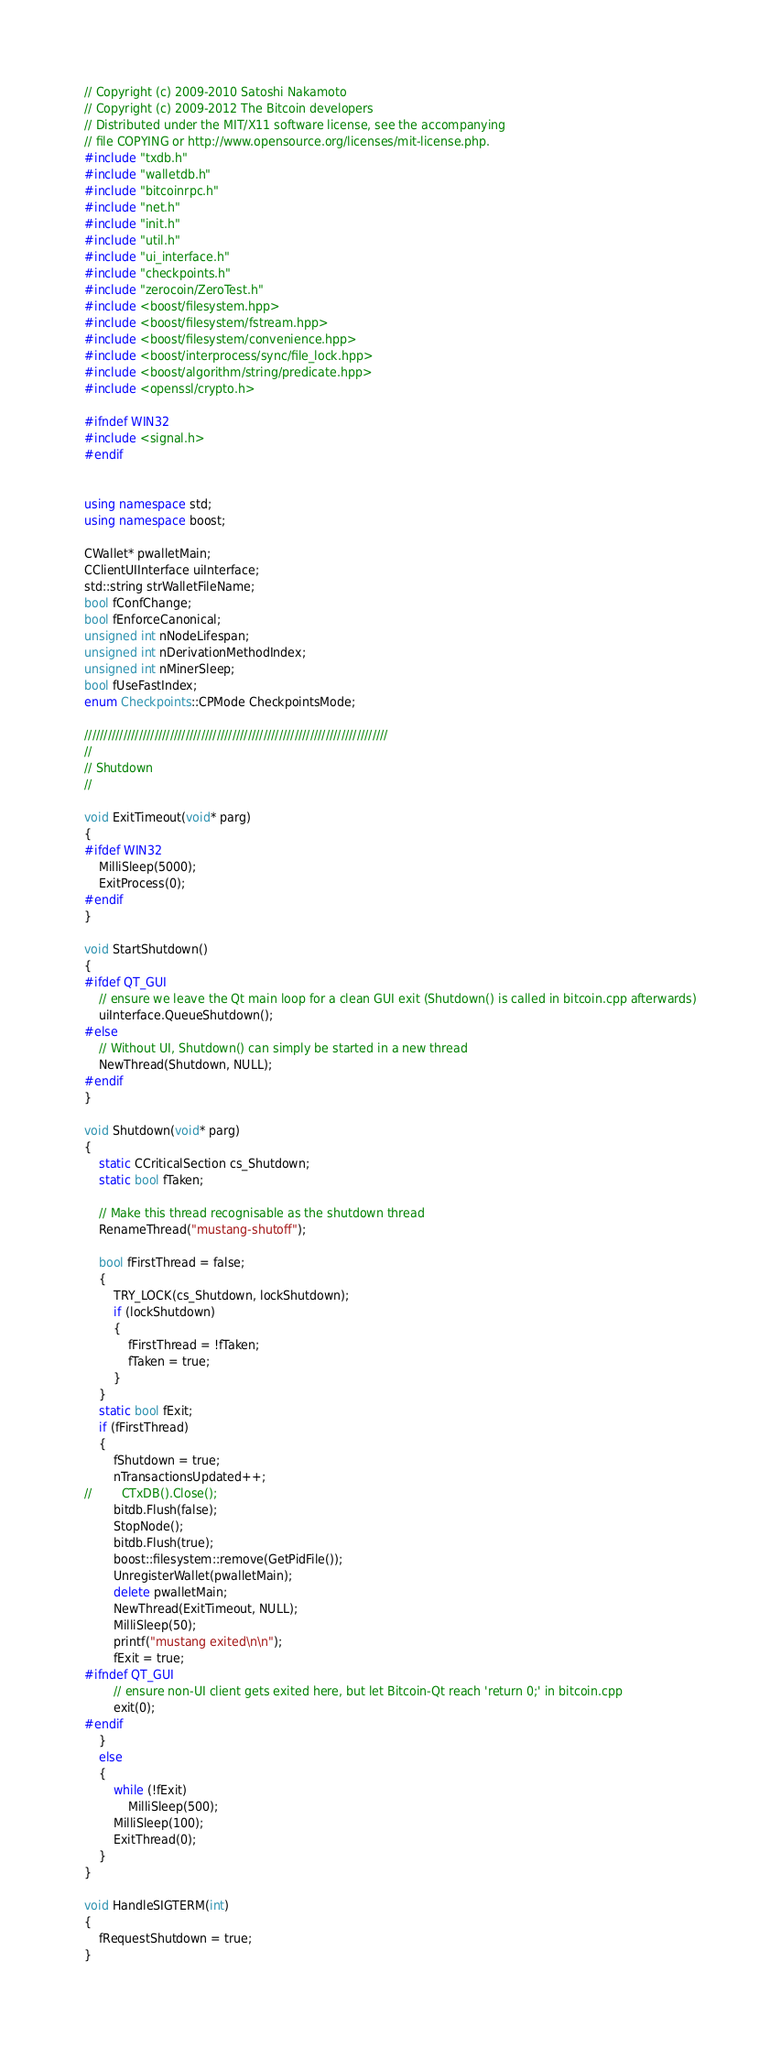<code> <loc_0><loc_0><loc_500><loc_500><_C++_>// Copyright (c) 2009-2010 Satoshi Nakamoto
// Copyright (c) 2009-2012 The Bitcoin developers
// Distributed under the MIT/X11 software license, see the accompanying
// file COPYING or http://www.opensource.org/licenses/mit-license.php.
#include "txdb.h"
#include "walletdb.h"
#include "bitcoinrpc.h"
#include "net.h"
#include "init.h"
#include "util.h"
#include "ui_interface.h"
#include "checkpoints.h"
#include "zerocoin/ZeroTest.h"
#include <boost/filesystem.hpp>
#include <boost/filesystem/fstream.hpp>
#include <boost/filesystem/convenience.hpp>
#include <boost/interprocess/sync/file_lock.hpp>
#include <boost/algorithm/string/predicate.hpp>
#include <openssl/crypto.h>

#ifndef WIN32
#include <signal.h>
#endif


using namespace std;
using namespace boost;

CWallet* pwalletMain;
CClientUIInterface uiInterface;
std::string strWalletFileName;
bool fConfChange;
bool fEnforceCanonical;
unsigned int nNodeLifespan;
unsigned int nDerivationMethodIndex;
unsigned int nMinerSleep;
bool fUseFastIndex;
enum Checkpoints::CPMode CheckpointsMode;

//////////////////////////////////////////////////////////////////////////////
//
// Shutdown
//

void ExitTimeout(void* parg)
{
#ifdef WIN32
    MilliSleep(5000);
    ExitProcess(0);
#endif
}

void StartShutdown()
{
#ifdef QT_GUI
    // ensure we leave the Qt main loop for a clean GUI exit (Shutdown() is called in bitcoin.cpp afterwards)
    uiInterface.QueueShutdown();
#else
    // Without UI, Shutdown() can simply be started in a new thread
    NewThread(Shutdown, NULL);
#endif
}

void Shutdown(void* parg)
{
    static CCriticalSection cs_Shutdown;
    static bool fTaken;

    // Make this thread recognisable as the shutdown thread
    RenameThread("mustang-shutoff");

    bool fFirstThread = false;
    {
        TRY_LOCK(cs_Shutdown, lockShutdown);
        if (lockShutdown)
        {
            fFirstThread = !fTaken;
            fTaken = true;
        }
    }
    static bool fExit;
    if (fFirstThread)
    {
        fShutdown = true;
        nTransactionsUpdated++;
//        CTxDB().Close();
        bitdb.Flush(false);
        StopNode();
        bitdb.Flush(true);
        boost::filesystem::remove(GetPidFile());
        UnregisterWallet(pwalletMain);
        delete pwalletMain;
        NewThread(ExitTimeout, NULL);
        MilliSleep(50);
        printf("mustang exited\n\n");
        fExit = true;
#ifndef QT_GUI
        // ensure non-UI client gets exited here, but let Bitcoin-Qt reach 'return 0;' in bitcoin.cpp
        exit(0);
#endif
    }
    else
    {
        while (!fExit)
            MilliSleep(500);
        MilliSleep(100);
        ExitThread(0);
    }
}

void HandleSIGTERM(int)
{
    fRequestShutdown = true;
}
</code> 